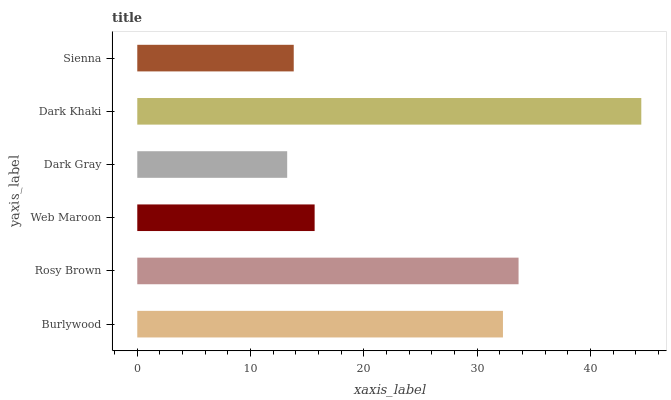Is Dark Gray the minimum?
Answer yes or no. Yes. Is Dark Khaki the maximum?
Answer yes or no. Yes. Is Rosy Brown the minimum?
Answer yes or no. No. Is Rosy Brown the maximum?
Answer yes or no. No. Is Rosy Brown greater than Burlywood?
Answer yes or no. Yes. Is Burlywood less than Rosy Brown?
Answer yes or no. Yes. Is Burlywood greater than Rosy Brown?
Answer yes or no. No. Is Rosy Brown less than Burlywood?
Answer yes or no. No. Is Burlywood the high median?
Answer yes or no. Yes. Is Web Maroon the low median?
Answer yes or no. Yes. Is Web Maroon the high median?
Answer yes or no. No. Is Rosy Brown the low median?
Answer yes or no. No. 